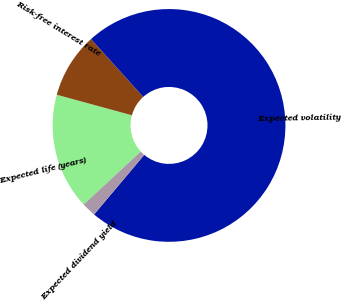<chart> <loc_0><loc_0><loc_500><loc_500><pie_chart><fcel>Expected life (years)<fcel>Risk-free interest rate<fcel>Expected volatility<fcel>Expected dividend yield<nl><fcel>16.14%<fcel>9.06%<fcel>72.83%<fcel>1.97%<nl></chart> 